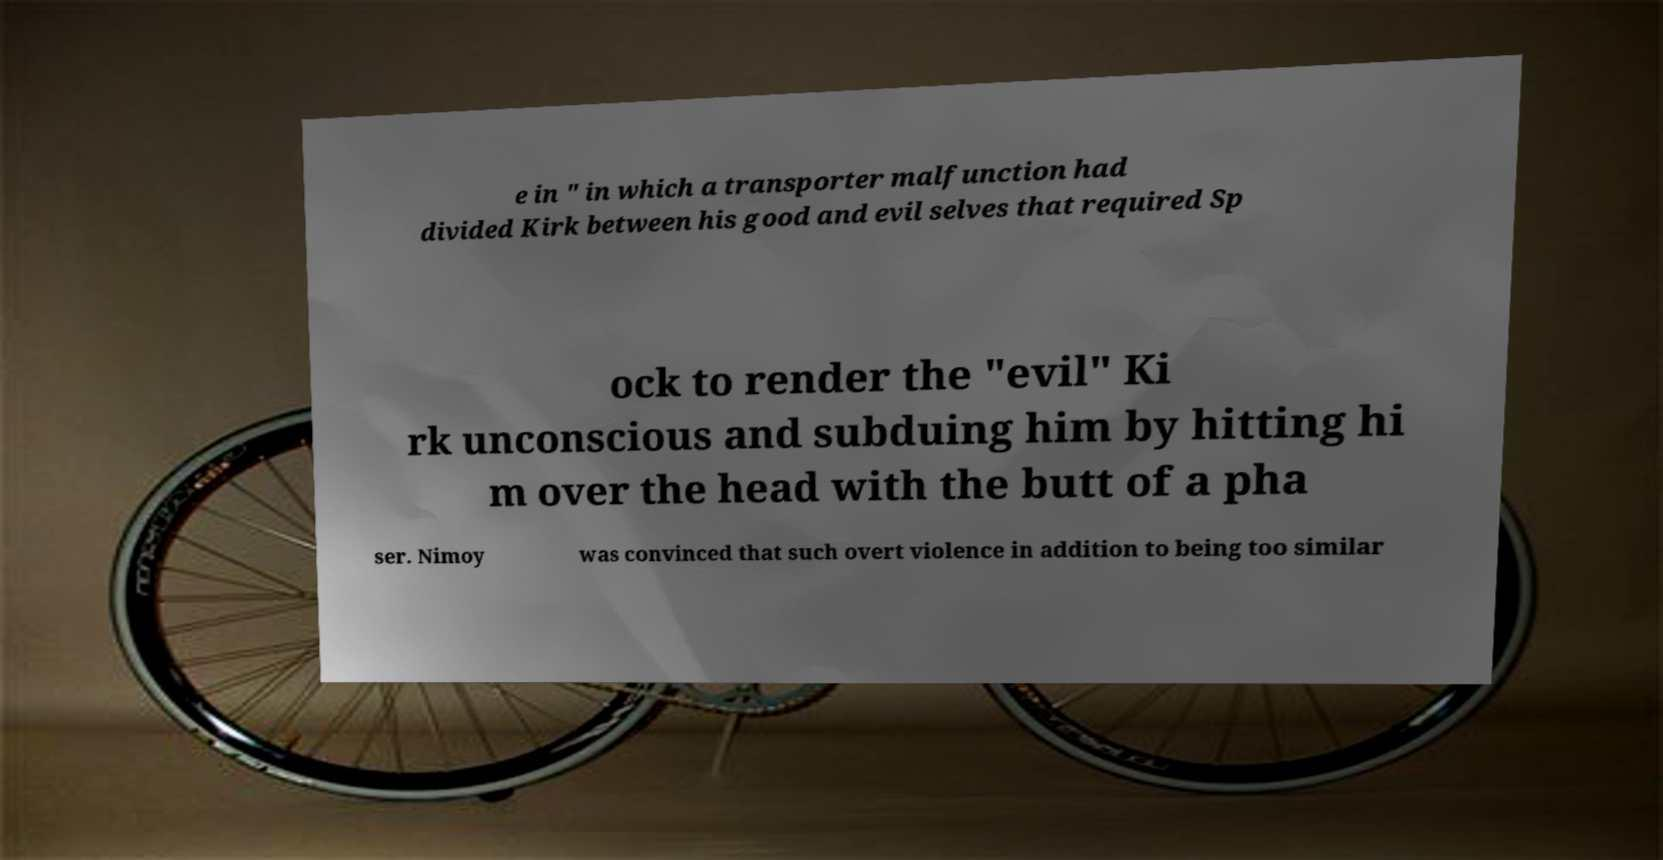For documentation purposes, I need the text within this image transcribed. Could you provide that? e in " in which a transporter malfunction had divided Kirk between his good and evil selves that required Sp ock to render the "evil" Ki rk unconscious and subduing him by hitting hi m over the head with the butt of a pha ser. Nimoy was convinced that such overt violence in addition to being too similar 